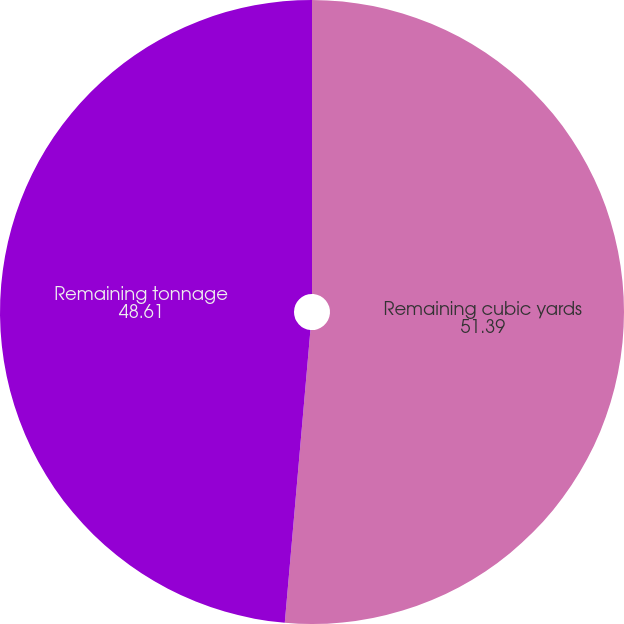Convert chart to OTSL. <chart><loc_0><loc_0><loc_500><loc_500><pie_chart><fcel>Remaining cubic yards<fcel>Remaining tonnage<nl><fcel>51.39%<fcel>48.61%<nl></chart> 